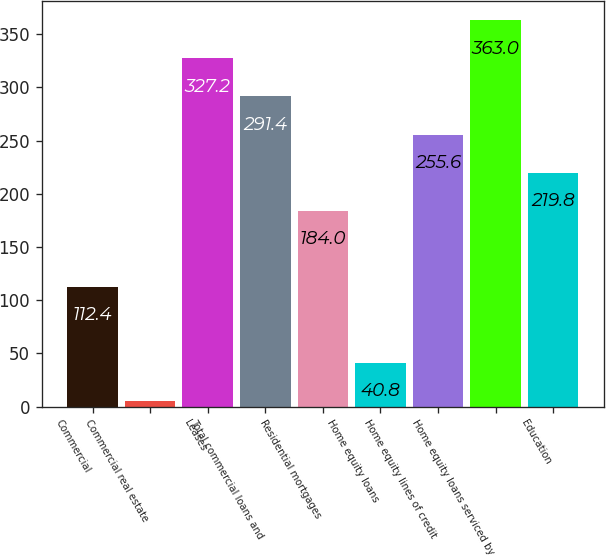<chart> <loc_0><loc_0><loc_500><loc_500><bar_chart><fcel>Commercial<fcel>Commercial real estate<fcel>Leases<fcel>Total commercial loans and<fcel>Residential mortgages<fcel>Home equity loans<fcel>Home equity lines of credit<fcel>Home equity loans serviced by<fcel>Education<nl><fcel>112.4<fcel>5<fcel>327.2<fcel>291.4<fcel>184<fcel>40.8<fcel>255.6<fcel>363<fcel>219.8<nl></chart> 